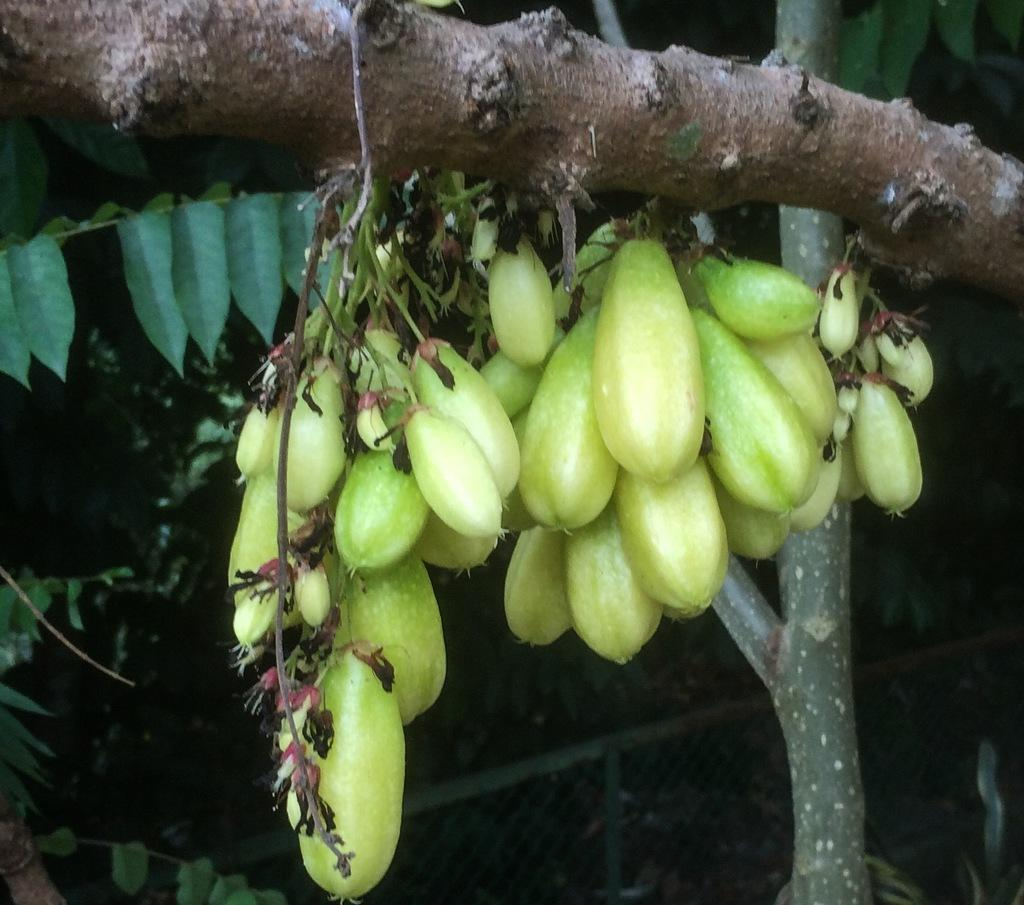What type of objects can be seen on the branch of the tree in the image? There are fruits on the branch of the tree in the image. What type of brick is being used to build the airplane in the image? There is no brick or airplane present in the image; it only features fruits on the branch of a tree. 